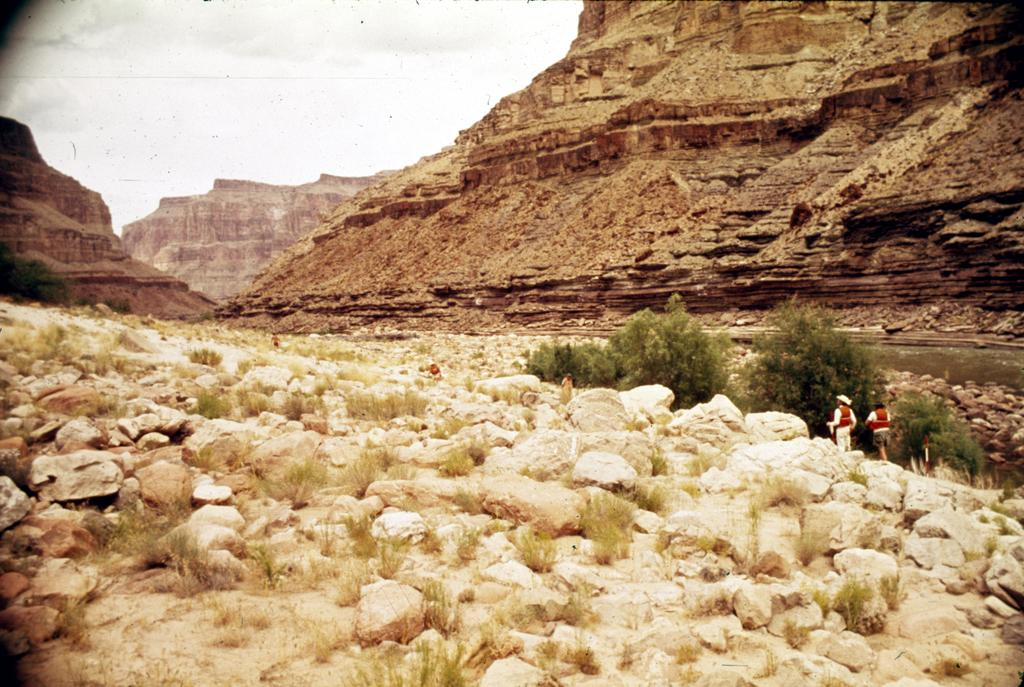What type of natural elements can be seen in the image? There are rocks and plants visible in the image. What are the people in the image doing? The people standing in the image are not performing any specific action, but their presence is noted. What can be seen on the right side of the image? There is water on the right side of the image. What is visible in the background of the image? There are mountains in the background of the image. What is visible at the top of the image? The sky is visible at the top of the image. How many apples are hanging from the trees in the image? There are no apples or trees present in the image; it features rocks, plants, people, water, mountains, and the sky. What type of coast can be seen in the image? There is no coast visible in the image; it does not depict a coastal area. 